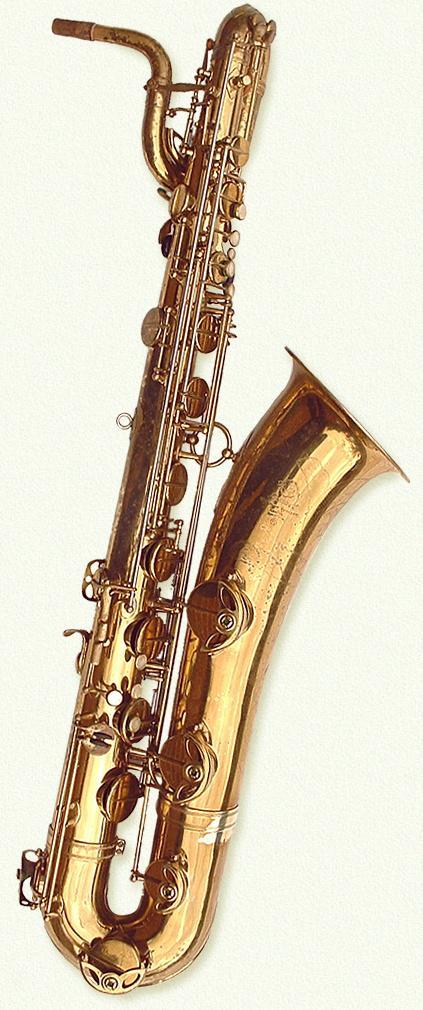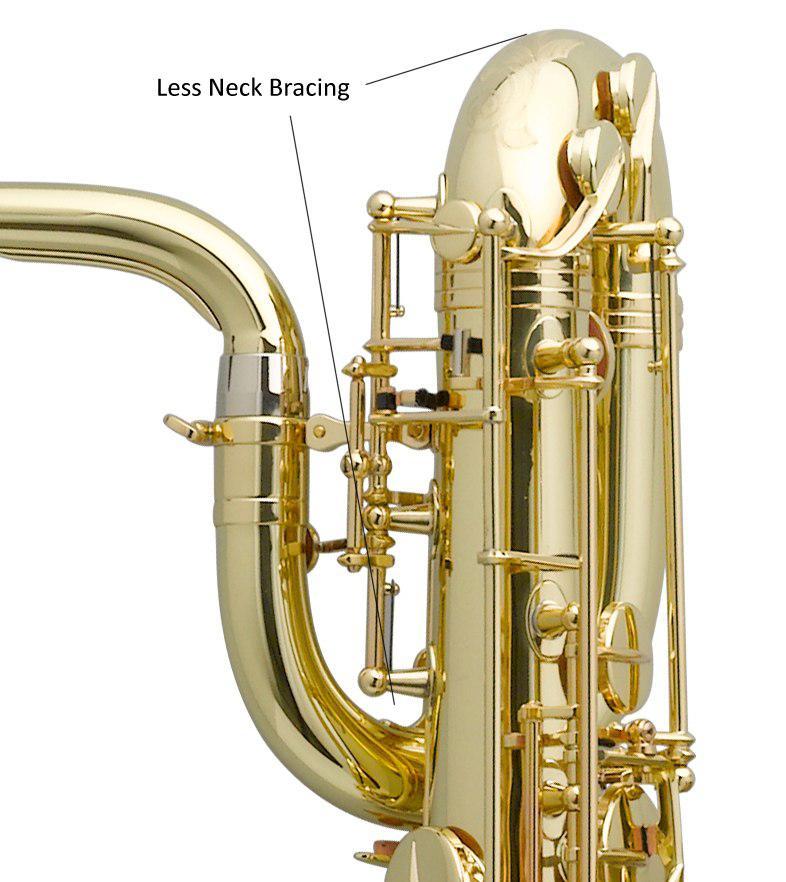The first image is the image on the left, the second image is the image on the right. Examine the images to the left and right. Is the description "There is exactly one black mouthpiece." accurate? Answer yes or no. No. The first image is the image on the left, the second image is the image on the right. Given the left and right images, does the statement "Each image shows one upright gold colored saxophone with its bell facing rightward and its mouthpiece facing leftward, and at least one of the saxophones pictured has a loop shape at the top." hold true? Answer yes or no. No. 